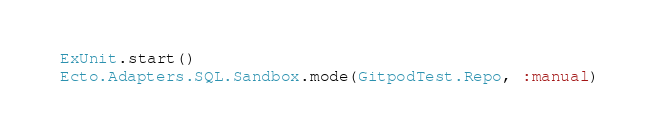Convert code to text. <code><loc_0><loc_0><loc_500><loc_500><_Elixir_>ExUnit.start()
Ecto.Adapters.SQL.Sandbox.mode(GitpodTest.Repo, :manual)
</code> 